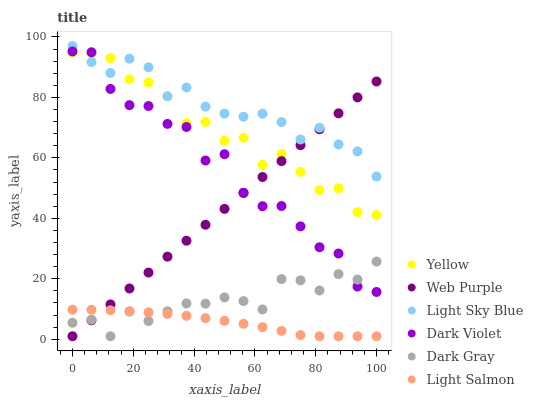Does Light Salmon have the minimum area under the curve?
Answer yes or no. Yes. Does Light Sky Blue have the maximum area under the curve?
Answer yes or no. Yes. Does Dark Violet have the minimum area under the curve?
Answer yes or no. No. Does Dark Violet have the maximum area under the curve?
Answer yes or no. No. Is Web Purple the smoothest?
Answer yes or no. Yes. Is Dark Violet the roughest?
Answer yes or no. Yes. Is Dark Gray the smoothest?
Answer yes or no. No. Is Dark Gray the roughest?
Answer yes or no. No. Does Light Salmon have the lowest value?
Answer yes or no. Yes. Does Dark Violet have the lowest value?
Answer yes or no. No. Does Light Sky Blue have the highest value?
Answer yes or no. Yes. Does Dark Violet have the highest value?
Answer yes or no. No. Is Light Salmon less than Dark Violet?
Answer yes or no. Yes. Is Yellow greater than Light Salmon?
Answer yes or no. Yes. Does Web Purple intersect Dark Gray?
Answer yes or no. Yes. Is Web Purple less than Dark Gray?
Answer yes or no. No. Is Web Purple greater than Dark Gray?
Answer yes or no. No. Does Light Salmon intersect Dark Violet?
Answer yes or no. No. 